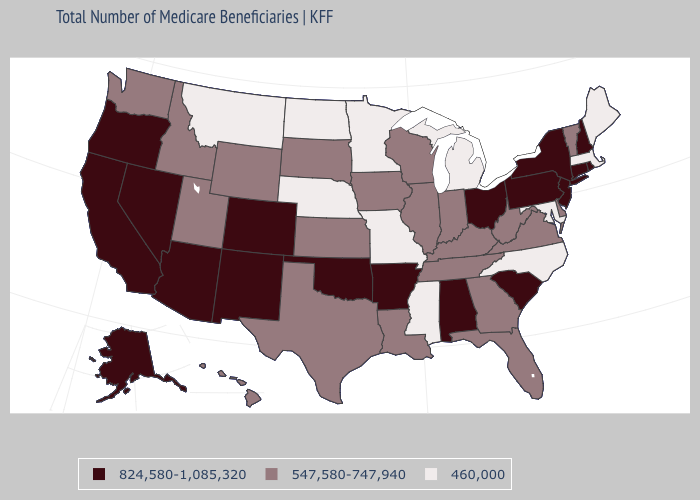Name the states that have a value in the range 460,000?
Concise answer only. Maine, Maryland, Massachusetts, Michigan, Minnesota, Mississippi, Missouri, Montana, Nebraska, North Carolina, North Dakota. Does Washington have a lower value than Alabama?
Concise answer only. Yes. Does the first symbol in the legend represent the smallest category?
Concise answer only. No. Name the states that have a value in the range 460,000?
Concise answer only. Maine, Maryland, Massachusetts, Michigan, Minnesota, Mississippi, Missouri, Montana, Nebraska, North Carolina, North Dakota. What is the lowest value in the USA?
Write a very short answer. 460,000. Which states have the lowest value in the USA?
Write a very short answer. Maine, Maryland, Massachusetts, Michigan, Minnesota, Mississippi, Missouri, Montana, Nebraska, North Carolina, North Dakota. What is the value of Minnesota?
Be succinct. 460,000. Name the states that have a value in the range 547,580-747,940?
Keep it brief. Delaware, Florida, Georgia, Hawaii, Idaho, Illinois, Indiana, Iowa, Kansas, Kentucky, Louisiana, South Dakota, Tennessee, Texas, Utah, Vermont, Virginia, Washington, West Virginia, Wisconsin, Wyoming. What is the value of Maine?
Keep it brief. 460,000. Name the states that have a value in the range 547,580-747,940?
Answer briefly. Delaware, Florida, Georgia, Hawaii, Idaho, Illinois, Indiana, Iowa, Kansas, Kentucky, Louisiana, South Dakota, Tennessee, Texas, Utah, Vermont, Virginia, Washington, West Virginia, Wisconsin, Wyoming. Name the states that have a value in the range 460,000?
Quick response, please. Maine, Maryland, Massachusetts, Michigan, Minnesota, Mississippi, Missouri, Montana, Nebraska, North Carolina, North Dakota. Does South Dakota have the same value as Maine?
Short answer required. No. Does Ohio have the highest value in the MidWest?
Concise answer only. Yes. What is the value of Missouri?
Short answer required. 460,000. Which states hav the highest value in the West?
Keep it brief. Alaska, Arizona, California, Colorado, Nevada, New Mexico, Oregon. 